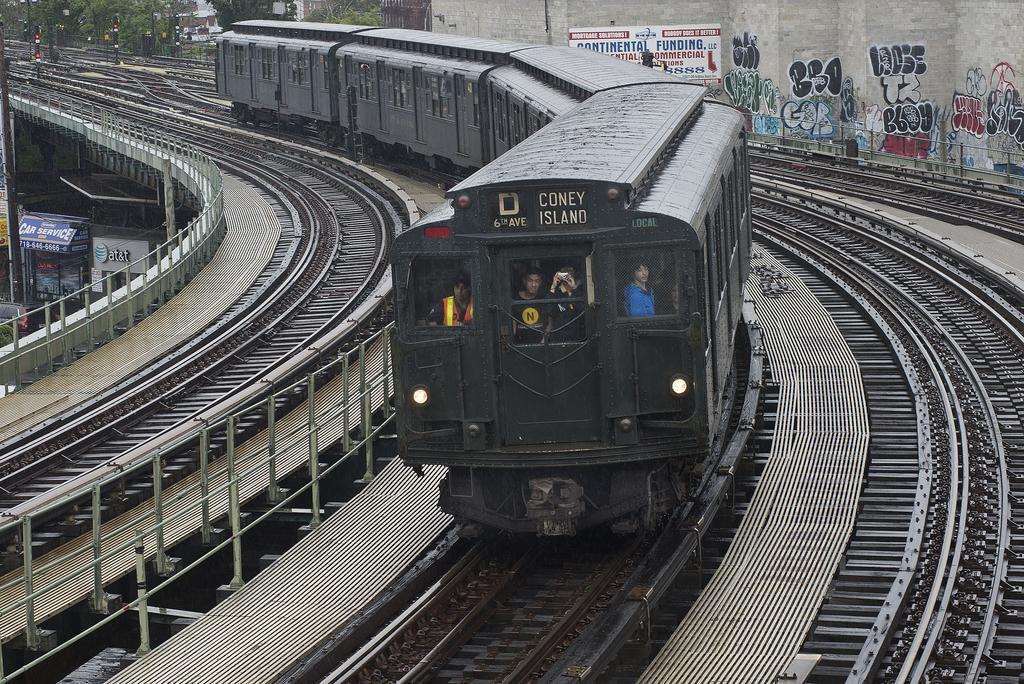<image>
Present a compact description of the photo's key features. The D train comes around a bend in the middle of multiple tracks. 